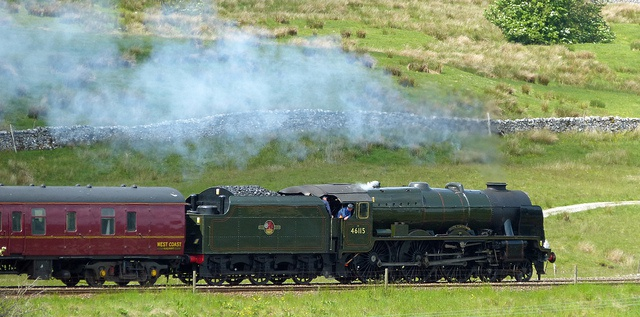Describe the objects in this image and their specific colors. I can see train in darkgray, black, gray, maroon, and purple tones, people in darkgray, navy, gray, black, and blue tones, and people in darkgray, black, gray, and navy tones in this image. 